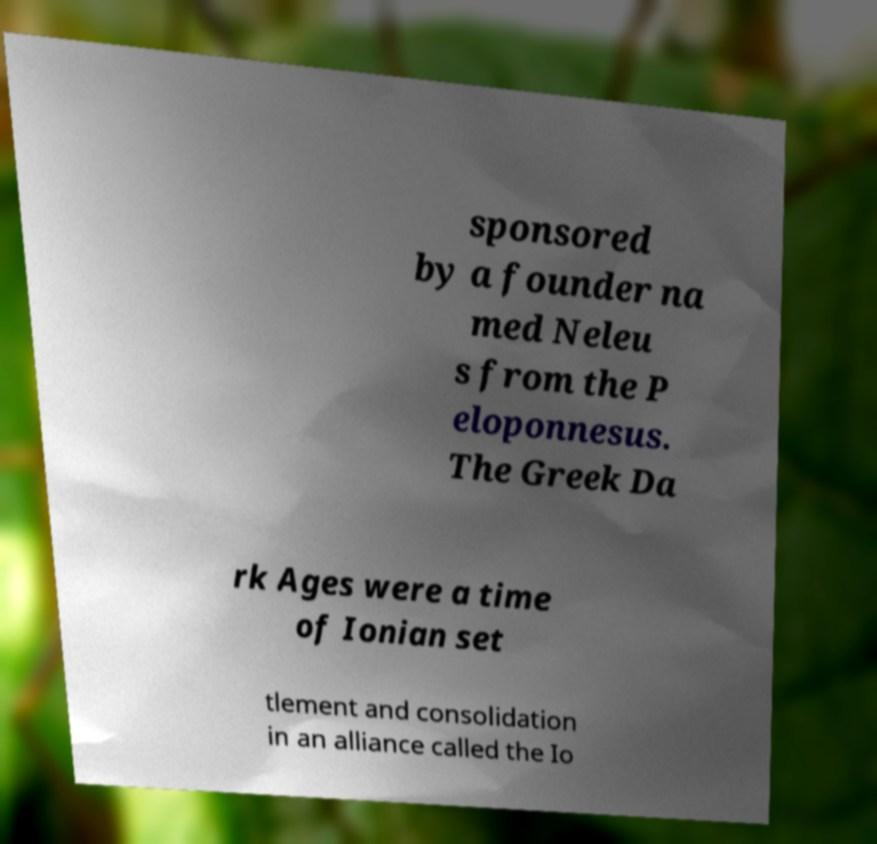Please identify and transcribe the text found in this image. sponsored by a founder na med Neleu s from the P eloponnesus. The Greek Da rk Ages were a time of Ionian set tlement and consolidation in an alliance called the Io 